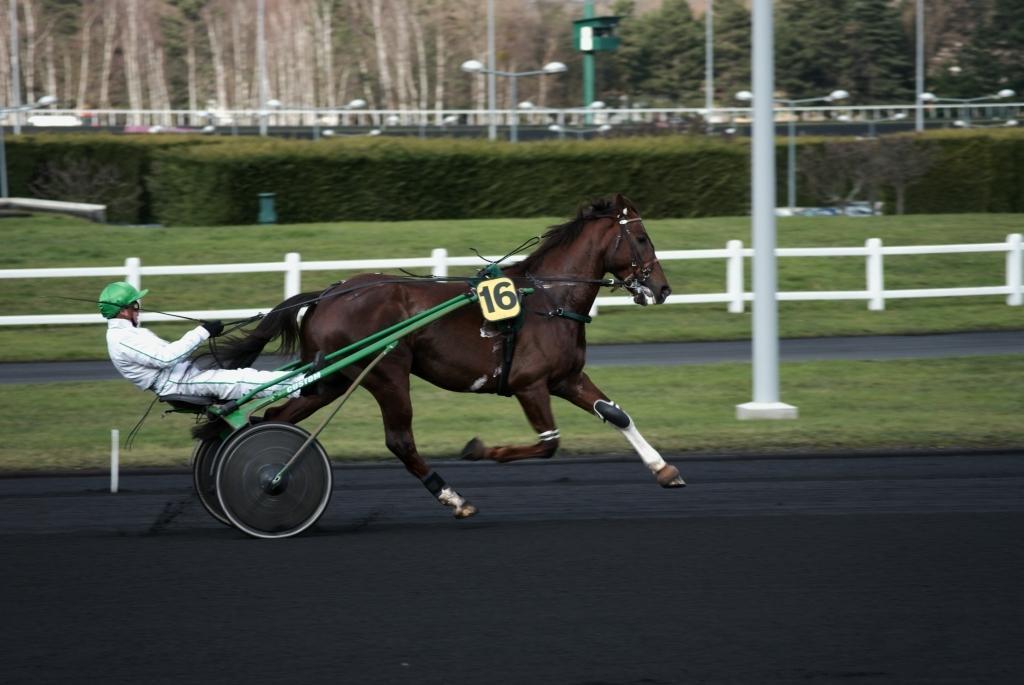Describe this image in one or two sentences. In this picture there is a person sitting and riding the horse. At the back there is a railing and there are trees and there are street lights. At the bottom there is a road and there is grass. 